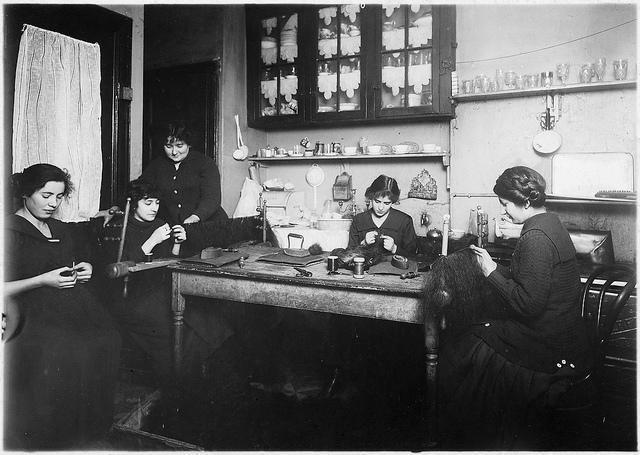How many people are there?
Give a very brief answer. 5. How many chairs are there?
Give a very brief answer. 2. 